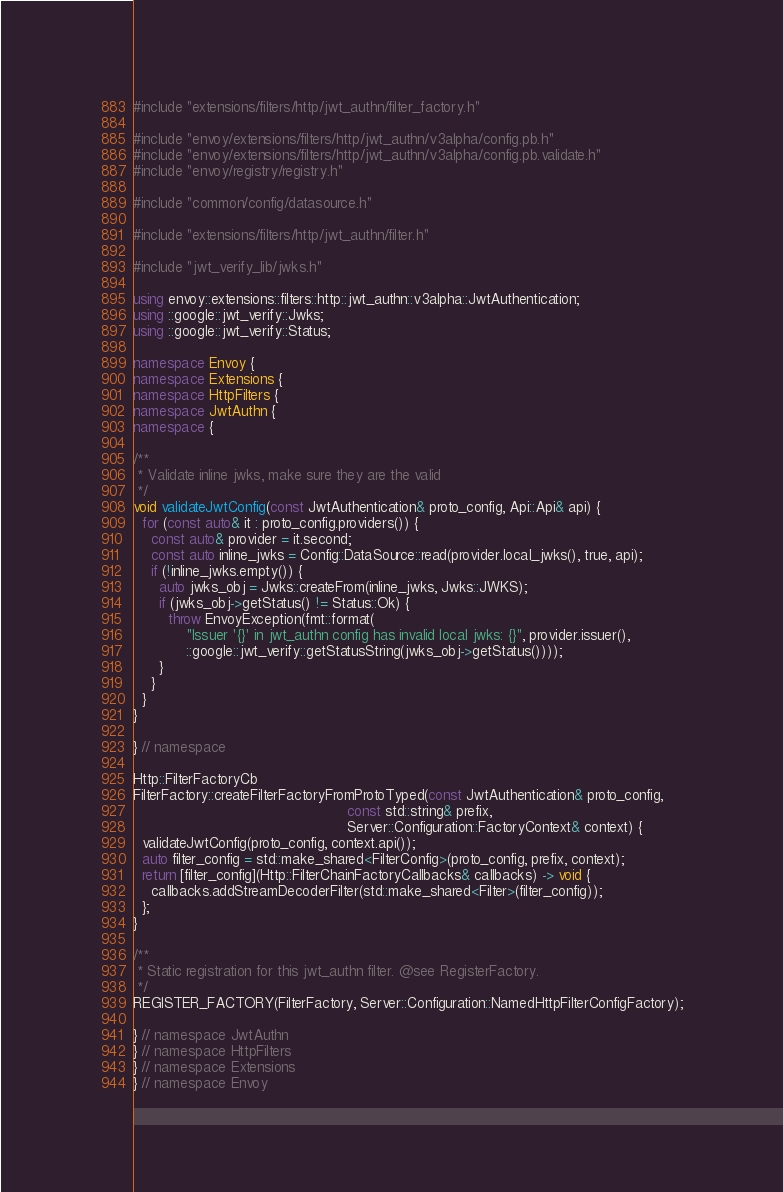<code> <loc_0><loc_0><loc_500><loc_500><_C++_>#include "extensions/filters/http/jwt_authn/filter_factory.h"

#include "envoy/extensions/filters/http/jwt_authn/v3alpha/config.pb.h"
#include "envoy/extensions/filters/http/jwt_authn/v3alpha/config.pb.validate.h"
#include "envoy/registry/registry.h"

#include "common/config/datasource.h"

#include "extensions/filters/http/jwt_authn/filter.h"

#include "jwt_verify_lib/jwks.h"

using envoy::extensions::filters::http::jwt_authn::v3alpha::JwtAuthentication;
using ::google::jwt_verify::Jwks;
using ::google::jwt_verify::Status;

namespace Envoy {
namespace Extensions {
namespace HttpFilters {
namespace JwtAuthn {
namespace {

/**
 * Validate inline jwks, make sure they are the valid
 */
void validateJwtConfig(const JwtAuthentication& proto_config, Api::Api& api) {
  for (const auto& it : proto_config.providers()) {
    const auto& provider = it.second;
    const auto inline_jwks = Config::DataSource::read(provider.local_jwks(), true, api);
    if (!inline_jwks.empty()) {
      auto jwks_obj = Jwks::createFrom(inline_jwks, Jwks::JWKS);
      if (jwks_obj->getStatus() != Status::Ok) {
        throw EnvoyException(fmt::format(
            "Issuer '{}' in jwt_authn config has invalid local jwks: {}", provider.issuer(),
            ::google::jwt_verify::getStatusString(jwks_obj->getStatus())));
      }
    }
  }
}

} // namespace

Http::FilterFactoryCb
FilterFactory::createFilterFactoryFromProtoTyped(const JwtAuthentication& proto_config,
                                                 const std::string& prefix,
                                                 Server::Configuration::FactoryContext& context) {
  validateJwtConfig(proto_config, context.api());
  auto filter_config = std::make_shared<FilterConfig>(proto_config, prefix, context);
  return [filter_config](Http::FilterChainFactoryCallbacks& callbacks) -> void {
    callbacks.addStreamDecoderFilter(std::make_shared<Filter>(filter_config));
  };
}

/**
 * Static registration for this jwt_authn filter. @see RegisterFactory.
 */
REGISTER_FACTORY(FilterFactory, Server::Configuration::NamedHttpFilterConfigFactory);

} // namespace JwtAuthn
} // namespace HttpFilters
} // namespace Extensions
} // namespace Envoy
</code> 